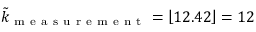<formula> <loc_0><loc_0><loc_500><loc_500>\tilde { k } _ { m e a s u r e m e n t } = \left \lfloor 1 2 . 4 2 \right \rfloor = 1 2</formula> 